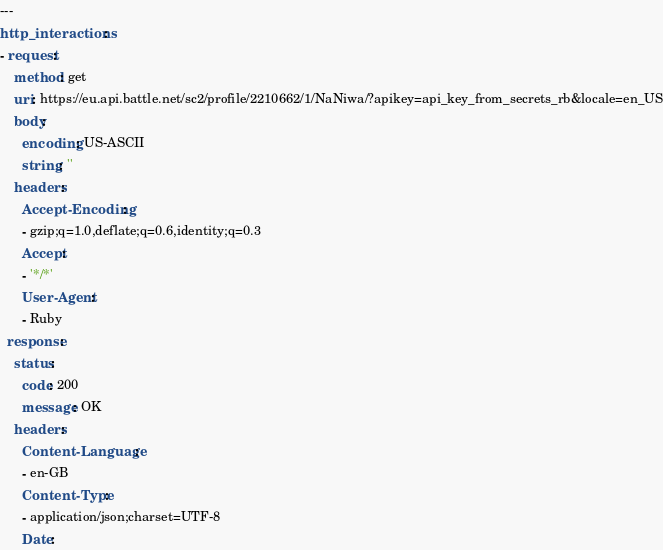<code> <loc_0><loc_0><loc_500><loc_500><_YAML_>---
http_interactions:
- request:
    method: get
    uri: https://eu.api.battle.net/sc2/profile/2210662/1/NaNiwa/?apikey=api_key_from_secrets_rb&locale=en_US
    body:
      encoding: US-ASCII
      string: ''
    headers:
      Accept-Encoding:
      - gzip;q=1.0,deflate;q=0.6,identity;q=0.3
      Accept:
      - '*/*'
      User-Agent:
      - Ruby
  response:
    status:
      code: 200
      message: OK
    headers:
      Content-Language:
      - en-GB
      Content-Type:
      - application/json;charset=UTF-8
      Date:</code> 